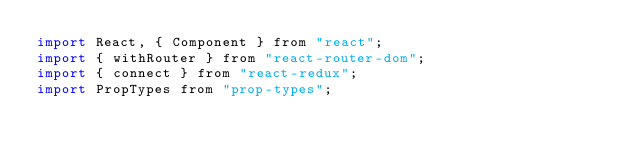<code> <loc_0><loc_0><loc_500><loc_500><_JavaScript_>import React, { Component } from "react";
import { withRouter } from "react-router-dom";
import { connect } from "react-redux";
import PropTypes from "prop-types";</code> 